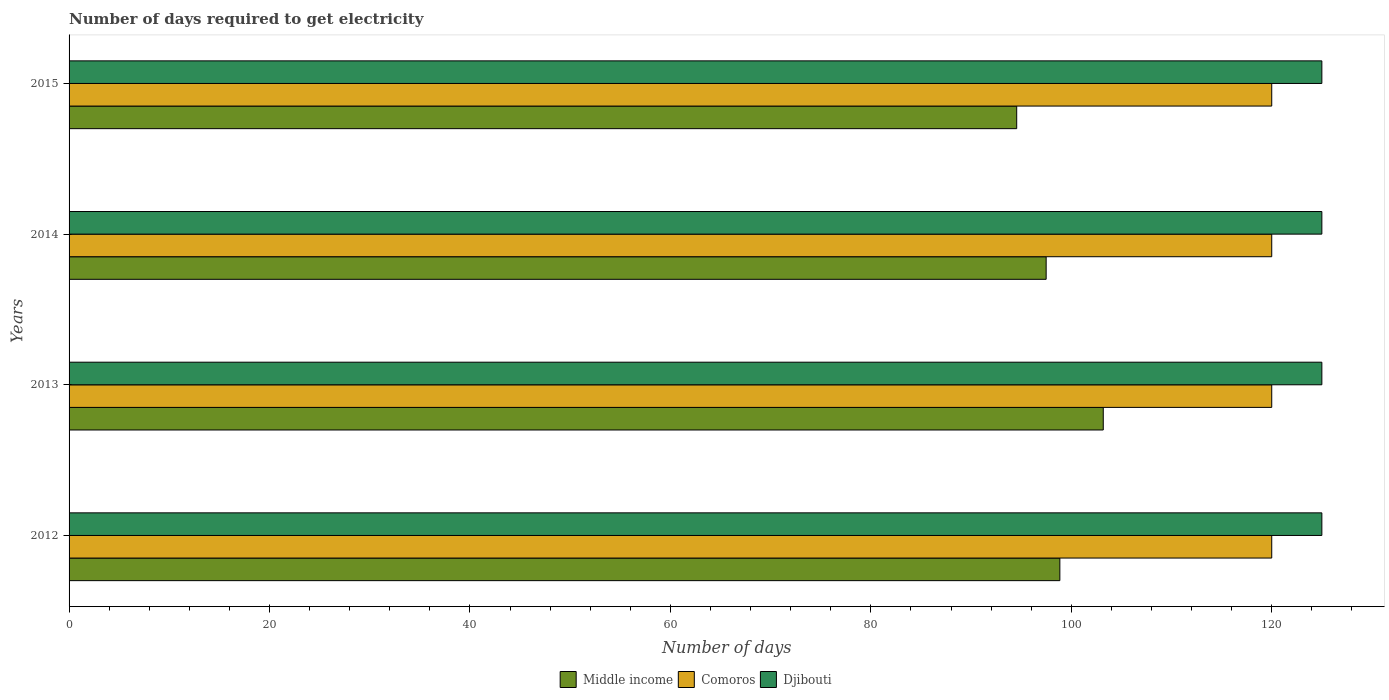How many different coloured bars are there?
Offer a terse response. 3. Are the number of bars per tick equal to the number of legend labels?
Ensure brevity in your answer.  Yes. Are the number of bars on each tick of the Y-axis equal?
Your answer should be very brief. Yes. How many bars are there on the 3rd tick from the top?
Give a very brief answer. 3. How many bars are there on the 1st tick from the bottom?
Your answer should be very brief. 3. In how many cases, is the number of bars for a given year not equal to the number of legend labels?
Your response must be concise. 0. What is the number of days required to get electricity in in Djibouti in 2012?
Provide a succinct answer. 125. Across all years, what is the maximum number of days required to get electricity in in Middle income?
Give a very brief answer. 103.19. Across all years, what is the minimum number of days required to get electricity in in Middle income?
Your answer should be very brief. 94.55. In which year was the number of days required to get electricity in in Middle income maximum?
Your response must be concise. 2013. What is the total number of days required to get electricity in in Middle income in the graph?
Your answer should be very brief. 394.09. What is the difference between the number of days required to get electricity in in Middle income in 2013 and that in 2015?
Your answer should be compact. 8.64. What is the difference between the number of days required to get electricity in in Middle income in 2014 and the number of days required to get electricity in in Comoros in 2012?
Offer a very short reply. -22.51. What is the average number of days required to get electricity in in Djibouti per year?
Make the answer very short. 125. In the year 2012, what is the difference between the number of days required to get electricity in in Comoros and number of days required to get electricity in in Djibouti?
Give a very brief answer. -5. In how many years, is the number of days required to get electricity in in Middle income greater than 20 days?
Your answer should be compact. 4. What is the ratio of the number of days required to get electricity in in Djibouti in 2012 to that in 2013?
Offer a terse response. 1. Is the number of days required to get electricity in in Comoros in 2012 less than that in 2015?
Keep it short and to the point. No. What is the difference between the highest and the lowest number of days required to get electricity in in Comoros?
Ensure brevity in your answer.  0. What does the 1st bar from the top in 2014 represents?
Ensure brevity in your answer.  Djibouti. What does the 2nd bar from the bottom in 2012 represents?
Offer a terse response. Comoros. How many bars are there?
Provide a short and direct response. 12. Are all the bars in the graph horizontal?
Provide a succinct answer. Yes. What is the difference between two consecutive major ticks on the X-axis?
Your response must be concise. 20. Are the values on the major ticks of X-axis written in scientific E-notation?
Provide a succinct answer. No. Does the graph contain grids?
Ensure brevity in your answer.  No. Where does the legend appear in the graph?
Give a very brief answer. Bottom center. How are the legend labels stacked?
Ensure brevity in your answer.  Horizontal. What is the title of the graph?
Keep it short and to the point. Number of days required to get electricity. Does "El Salvador" appear as one of the legend labels in the graph?
Give a very brief answer. No. What is the label or title of the X-axis?
Your response must be concise. Number of days. What is the label or title of the Y-axis?
Give a very brief answer. Years. What is the Number of days in Middle income in 2012?
Your answer should be very brief. 98.86. What is the Number of days of Comoros in 2012?
Keep it short and to the point. 120. What is the Number of days in Djibouti in 2012?
Offer a terse response. 125. What is the Number of days of Middle income in 2013?
Ensure brevity in your answer.  103.19. What is the Number of days in Comoros in 2013?
Give a very brief answer. 120. What is the Number of days of Djibouti in 2013?
Provide a succinct answer. 125. What is the Number of days in Middle income in 2014?
Your response must be concise. 97.49. What is the Number of days of Comoros in 2014?
Offer a very short reply. 120. What is the Number of days in Djibouti in 2014?
Give a very brief answer. 125. What is the Number of days of Middle income in 2015?
Your answer should be compact. 94.55. What is the Number of days of Comoros in 2015?
Give a very brief answer. 120. What is the Number of days of Djibouti in 2015?
Make the answer very short. 125. Across all years, what is the maximum Number of days of Middle income?
Provide a succinct answer. 103.19. Across all years, what is the maximum Number of days of Comoros?
Offer a terse response. 120. Across all years, what is the maximum Number of days in Djibouti?
Keep it short and to the point. 125. Across all years, what is the minimum Number of days of Middle income?
Your answer should be compact. 94.55. Across all years, what is the minimum Number of days of Comoros?
Give a very brief answer. 120. Across all years, what is the minimum Number of days of Djibouti?
Offer a terse response. 125. What is the total Number of days of Middle income in the graph?
Give a very brief answer. 394.09. What is the total Number of days in Comoros in the graph?
Offer a terse response. 480. What is the total Number of days in Djibouti in the graph?
Offer a terse response. 500. What is the difference between the Number of days of Middle income in 2012 and that in 2013?
Offer a terse response. -4.33. What is the difference between the Number of days in Djibouti in 2012 and that in 2013?
Keep it short and to the point. 0. What is the difference between the Number of days of Middle income in 2012 and that in 2014?
Your answer should be compact. 1.37. What is the difference between the Number of days in Comoros in 2012 and that in 2014?
Give a very brief answer. 0. What is the difference between the Number of days of Djibouti in 2012 and that in 2014?
Give a very brief answer. 0. What is the difference between the Number of days of Middle income in 2012 and that in 2015?
Ensure brevity in your answer.  4.31. What is the difference between the Number of days of Comoros in 2012 and that in 2015?
Offer a very short reply. 0. What is the difference between the Number of days of Middle income in 2013 and that in 2014?
Your answer should be compact. 5.7. What is the difference between the Number of days in Comoros in 2013 and that in 2014?
Ensure brevity in your answer.  0. What is the difference between the Number of days of Djibouti in 2013 and that in 2014?
Ensure brevity in your answer.  0. What is the difference between the Number of days in Middle income in 2013 and that in 2015?
Your answer should be very brief. 8.64. What is the difference between the Number of days of Comoros in 2013 and that in 2015?
Your response must be concise. 0. What is the difference between the Number of days in Djibouti in 2013 and that in 2015?
Offer a terse response. 0. What is the difference between the Number of days in Middle income in 2014 and that in 2015?
Make the answer very short. 2.94. What is the difference between the Number of days in Middle income in 2012 and the Number of days in Comoros in 2013?
Give a very brief answer. -21.14. What is the difference between the Number of days of Middle income in 2012 and the Number of days of Djibouti in 2013?
Your answer should be very brief. -26.14. What is the difference between the Number of days in Comoros in 2012 and the Number of days in Djibouti in 2013?
Make the answer very short. -5. What is the difference between the Number of days in Middle income in 2012 and the Number of days in Comoros in 2014?
Provide a short and direct response. -21.14. What is the difference between the Number of days of Middle income in 2012 and the Number of days of Djibouti in 2014?
Provide a short and direct response. -26.14. What is the difference between the Number of days in Comoros in 2012 and the Number of days in Djibouti in 2014?
Give a very brief answer. -5. What is the difference between the Number of days in Middle income in 2012 and the Number of days in Comoros in 2015?
Your response must be concise. -21.14. What is the difference between the Number of days of Middle income in 2012 and the Number of days of Djibouti in 2015?
Ensure brevity in your answer.  -26.14. What is the difference between the Number of days in Comoros in 2012 and the Number of days in Djibouti in 2015?
Give a very brief answer. -5. What is the difference between the Number of days of Middle income in 2013 and the Number of days of Comoros in 2014?
Offer a terse response. -16.81. What is the difference between the Number of days in Middle income in 2013 and the Number of days in Djibouti in 2014?
Make the answer very short. -21.81. What is the difference between the Number of days in Middle income in 2013 and the Number of days in Comoros in 2015?
Offer a terse response. -16.81. What is the difference between the Number of days in Middle income in 2013 and the Number of days in Djibouti in 2015?
Keep it short and to the point. -21.81. What is the difference between the Number of days of Comoros in 2013 and the Number of days of Djibouti in 2015?
Your answer should be very brief. -5. What is the difference between the Number of days in Middle income in 2014 and the Number of days in Comoros in 2015?
Your answer should be very brief. -22.51. What is the difference between the Number of days in Middle income in 2014 and the Number of days in Djibouti in 2015?
Make the answer very short. -27.51. What is the average Number of days in Middle income per year?
Offer a terse response. 98.52. What is the average Number of days of Comoros per year?
Provide a short and direct response. 120. What is the average Number of days of Djibouti per year?
Make the answer very short. 125. In the year 2012, what is the difference between the Number of days of Middle income and Number of days of Comoros?
Provide a succinct answer. -21.14. In the year 2012, what is the difference between the Number of days in Middle income and Number of days in Djibouti?
Make the answer very short. -26.14. In the year 2012, what is the difference between the Number of days in Comoros and Number of days in Djibouti?
Provide a short and direct response. -5. In the year 2013, what is the difference between the Number of days in Middle income and Number of days in Comoros?
Your response must be concise. -16.81. In the year 2013, what is the difference between the Number of days in Middle income and Number of days in Djibouti?
Give a very brief answer. -21.81. In the year 2013, what is the difference between the Number of days in Comoros and Number of days in Djibouti?
Your response must be concise. -5. In the year 2014, what is the difference between the Number of days of Middle income and Number of days of Comoros?
Your answer should be compact. -22.51. In the year 2014, what is the difference between the Number of days of Middle income and Number of days of Djibouti?
Your response must be concise. -27.51. In the year 2014, what is the difference between the Number of days in Comoros and Number of days in Djibouti?
Your response must be concise. -5. In the year 2015, what is the difference between the Number of days in Middle income and Number of days in Comoros?
Offer a terse response. -25.45. In the year 2015, what is the difference between the Number of days in Middle income and Number of days in Djibouti?
Your response must be concise. -30.45. What is the ratio of the Number of days of Middle income in 2012 to that in 2013?
Your answer should be compact. 0.96. What is the ratio of the Number of days in Comoros in 2012 to that in 2014?
Ensure brevity in your answer.  1. What is the ratio of the Number of days in Djibouti in 2012 to that in 2014?
Offer a terse response. 1. What is the ratio of the Number of days in Middle income in 2012 to that in 2015?
Offer a very short reply. 1.05. What is the ratio of the Number of days in Comoros in 2012 to that in 2015?
Your answer should be very brief. 1. What is the ratio of the Number of days in Middle income in 2013 to that in 2014?
Offer a terse response. 1.06. What is the ratio of the Number of days of Comoros in 2013 to that in 2014?
Your answer should be compact. 1. What is the ratio of the Number of days in Djibouti in 2013 to that in 2014?
Ensure brevity in your answer.  1. What is the ratio of the Number of days in Middle income in 2013 to that in 2015?
Your answer should be compact. 1.09. What is the ratio of the Number of days in Comoros in 2013 to that in 2015?
Provide a succinct answer. 1. What is the ratio of the Number of days in Djibouti in 2013 to that in 2015?
Make the answer very short. 1. What is the ratio of the Number of days in Middle income in 2014 to that in 2015?
Offer a very short reply. 1.03. What is the difference between the highest and the second highest Number of days in Middle income?
Provide a succinct answer. 4.33. What is the difference between the highest and the second highest Number of days in Comoros?
Offer a very short reply. 0. What is the difference between the highest and the lowest Number of days in Middle income?
Provide a short and direct response. 8.64. What is the difference between the highest and the lowest Number of days in Comoros?
Offer a terse response. 0. 